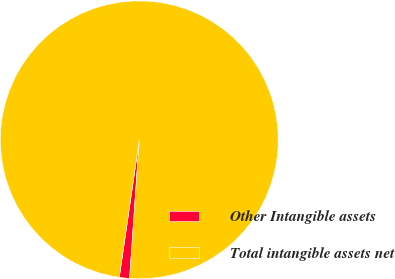<chart> <loc_0><loc_0><loc_500><loc_500><pie_chart><fcel>Other Intangible assets<fcel>Total intangible assets net<nl><fcel>1.19%<fcel>98.81%<nl></chart> 